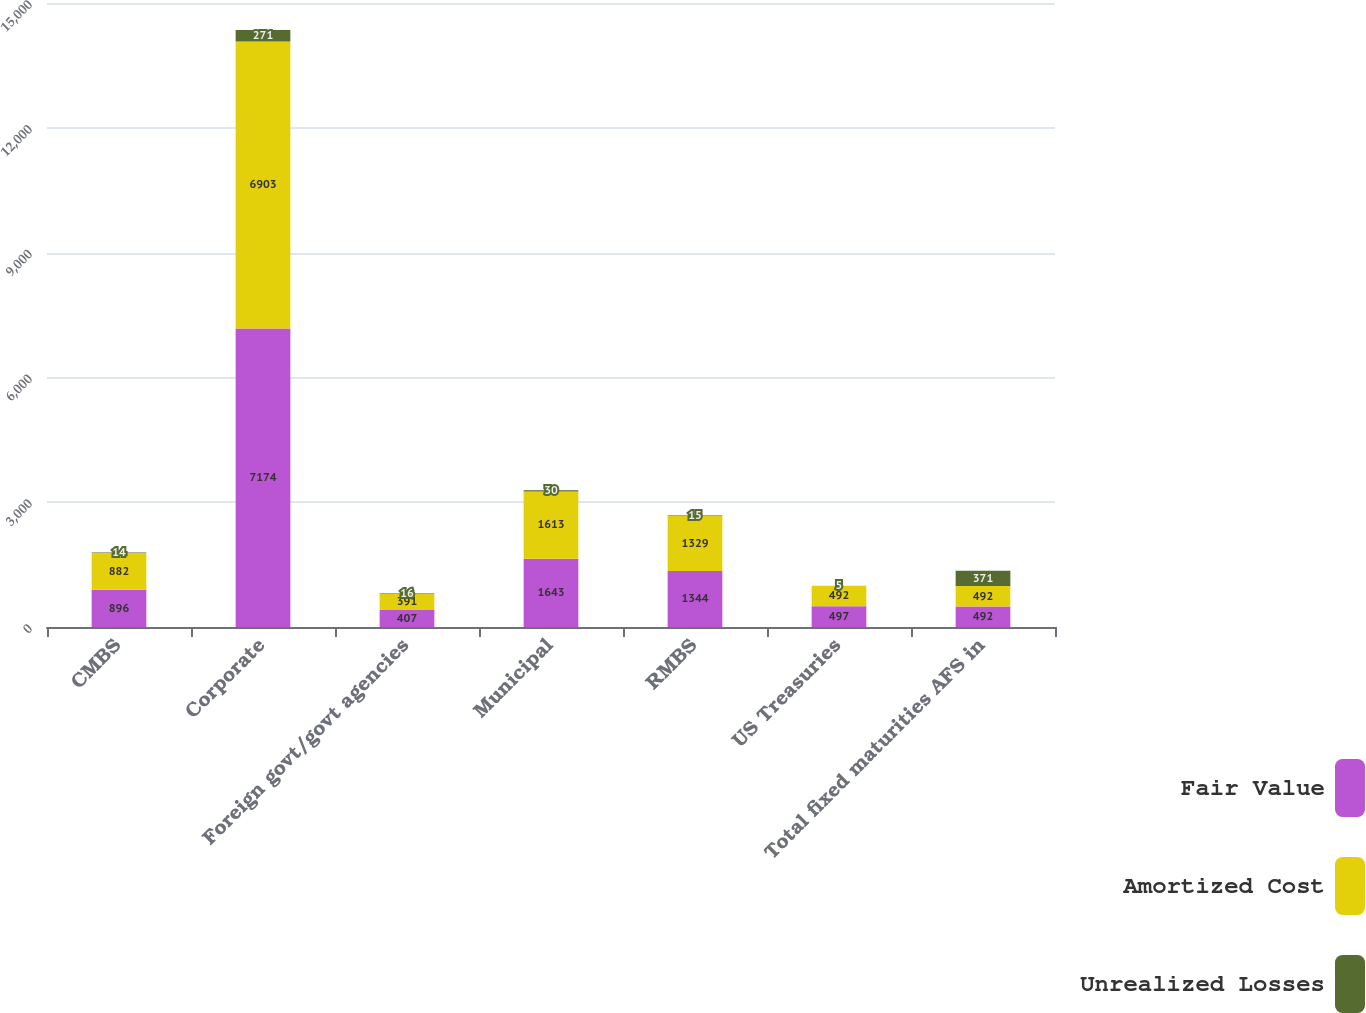<chart> <loc_0><loc_0><loc_500><loc_500><stacked_bar_chart><ecel><fcel>CMBS<fcel>Corporate<fcel>Foreign govt/govt agencies<fcel>Municipal<fcel>RMBS<fcel>US Treasuries<fcel>Total fixed maturities AFS in<nl><fcel>Fair Value<fcel>896<fcel>7174<fcel>407<fcel>1643<fcel>1344<fcel>497<fcel>492<nl><fcel>Amortized Cost<fcel>882<fcel>6903<fcel>391<fcel>1613<fcel>1329<fcel>492<fcel>492<nl><fcel>Unrealized Losses<fcel>14<fcel>271<fcel>16<fcel>30<fcel>15<fcel>5<fcel>371<nl></chart> 